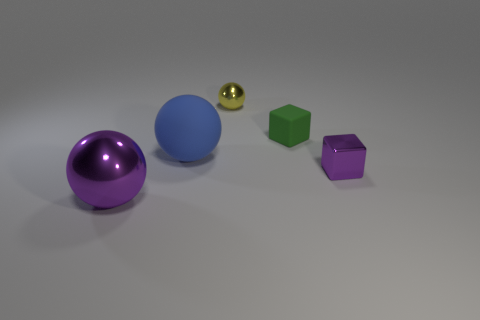Subtract all big blue matte balls. How many balls are left? 2 Add 2 yellow spheres. How many objects exist? 7 Subtract 1 balls. How many balls are left? 2 Subtract all cubes. How many objects are left? 3 Subtract all cyan blocks. Subtract all blue spheres. How many blocks are left? 2 Subtract all red matte cylinders. Subtract all purple objects. How many objects are left? 3 Add 3 blue rubber spheres. How many blue rubber spheres are left? 4 Add 2 small blue matte things. How many small blue matte things exist? 2 Subtract 0 cyan cylinders. How many objects are left? 5 